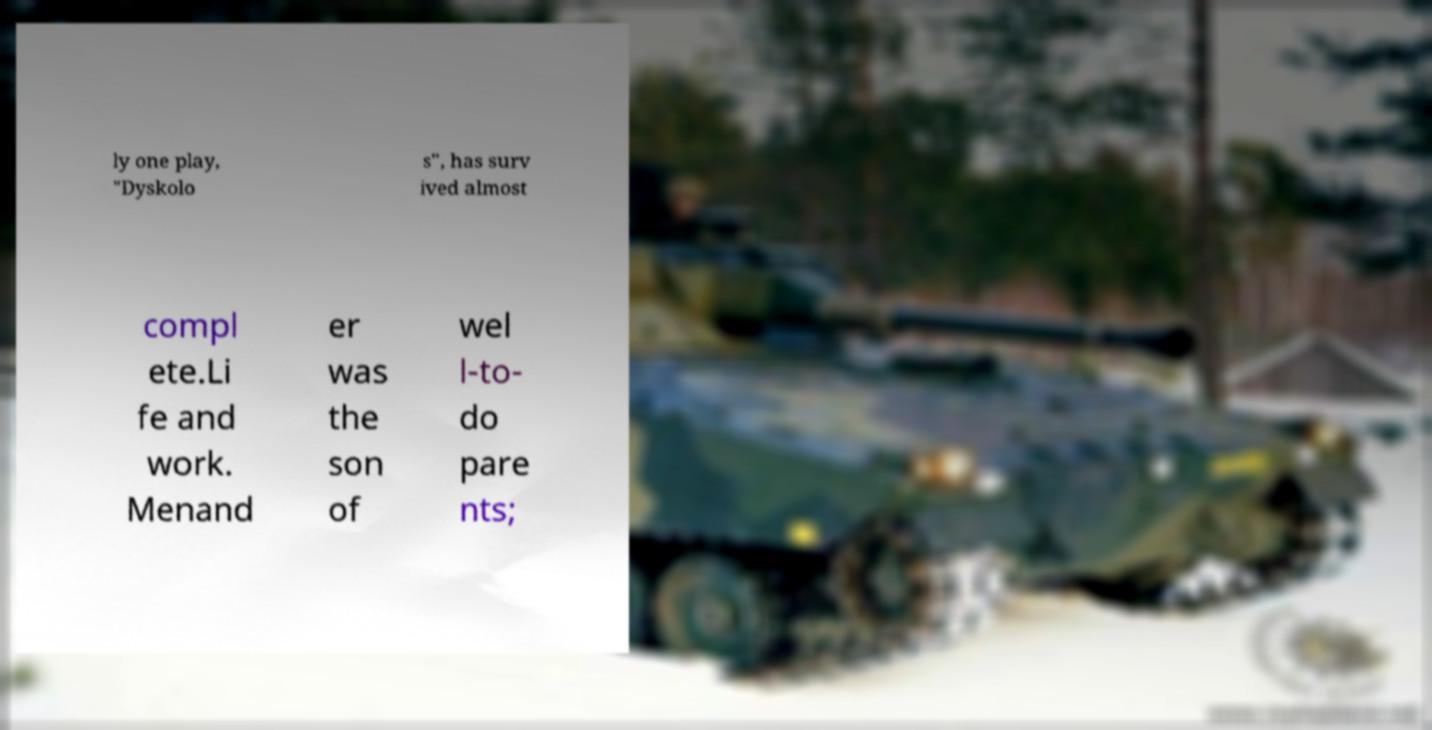Please read and relay the text visible in this image. What does it say? ly one play, "Dyskolo s", has surv ived almost compl ete.Li fe and work. Menand er was the son of wel l-to- do pare nts; 